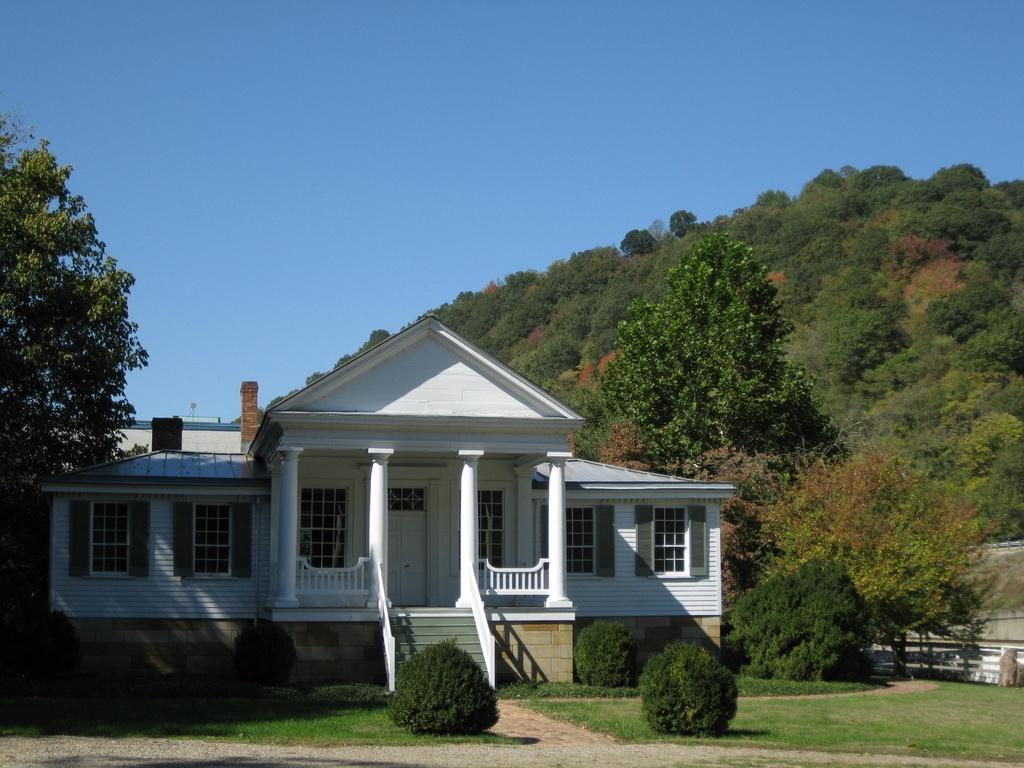What type of vegetation can be seen in the image? There are trees and plants in the image. What type of structures are visible in the image? There are houses in the image. What type of terrain is present in the image? There are hills in the image. What part of the natural environment is visible in the image? The sky is visible at the top of the image, and the ground is visible at the bottom of the image. Can you tell me who the authority figure is in the image? There is no authority figure present in the image. What type of rock can be seen in the image? There is no rock present in the image. Is there a person visible in the image? There is no person visible in the image. 